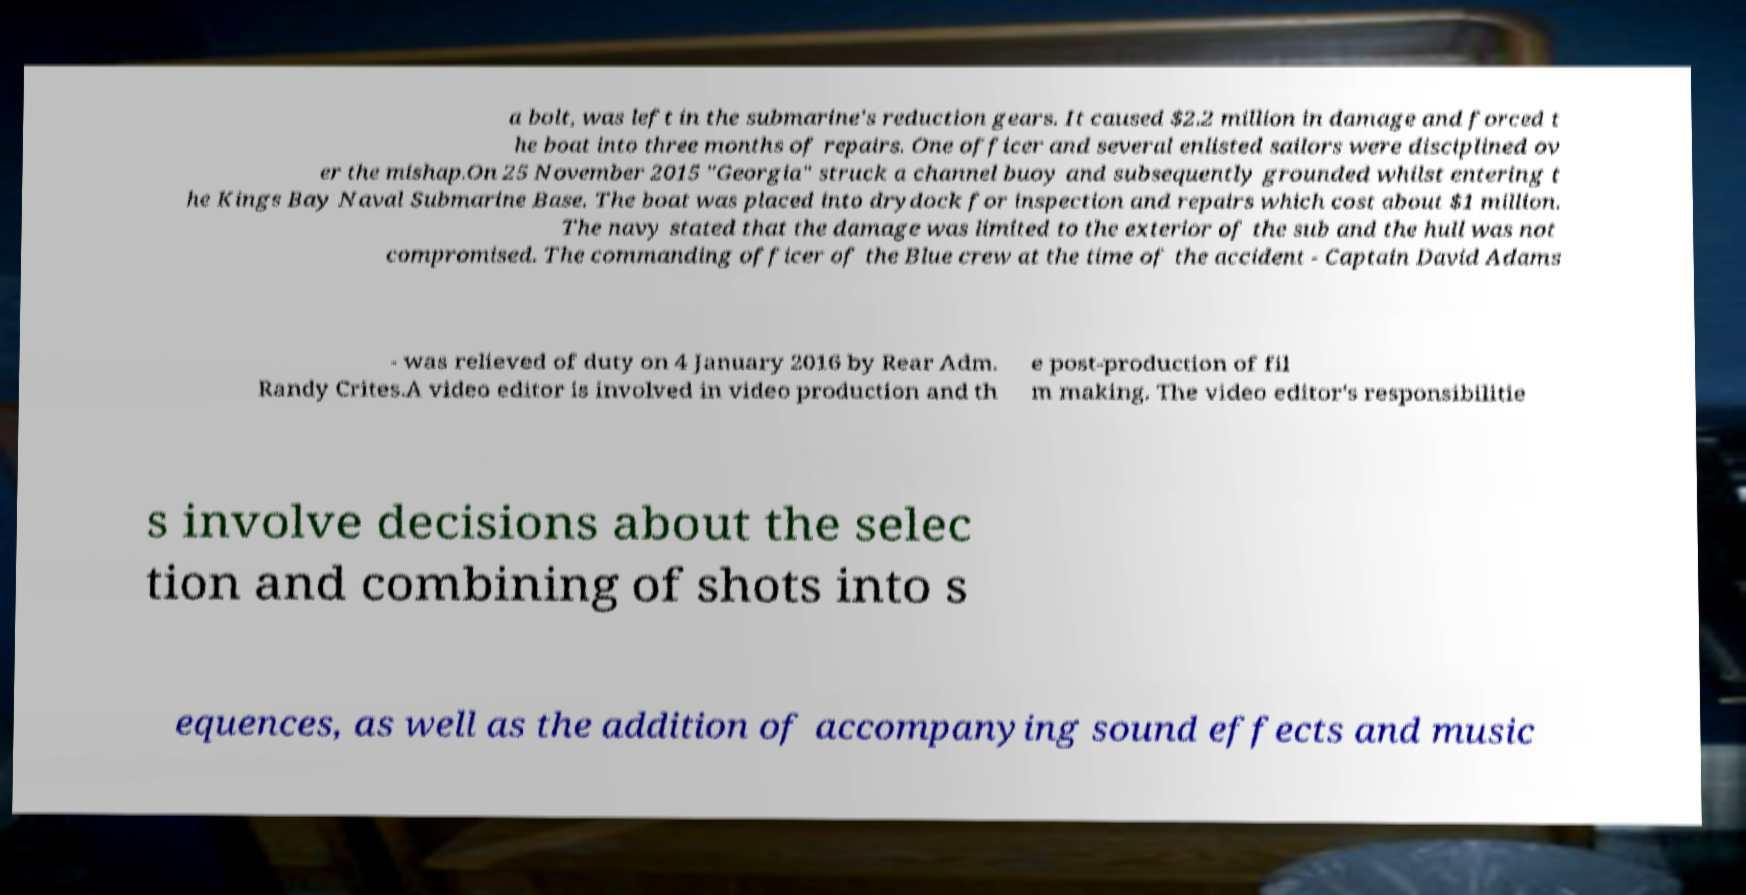Could you extract and type out the text from this image? a bolt, was left in the submarine's reduction gears. It caused $2.2 million in damage and forced t he boat into three months of repairs. One officer and several enlisted sailors were disciplined ov er the mishap.On 25 November 2015 "Georgia" struck a channel buoy and subsequently grounded whilst entering t he Kings Bay Naval Submarine Base. The boat was placed into drydock for inspection and repairs which cost about $1 million. The navy stated that the damage was limited to the exterior of the sub and the hull was not compromised. The commanding officer of the Blue crew at the time of the accident - Captain David Adams - was relieved of duty on 4 January 2016 by Rear Adm. Randy Crites.A video editor is involved in video production and th e post-production of fil m making. The video editor's responsibilitie s involve decisions about the selec tion and combining of shots into s equences, as well as the addition of accompanying sound effects and music 